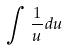<formula> <loc_0><loc_0><loc_500><loc_500>\int \frac { 1 } { u } d u</formula> 